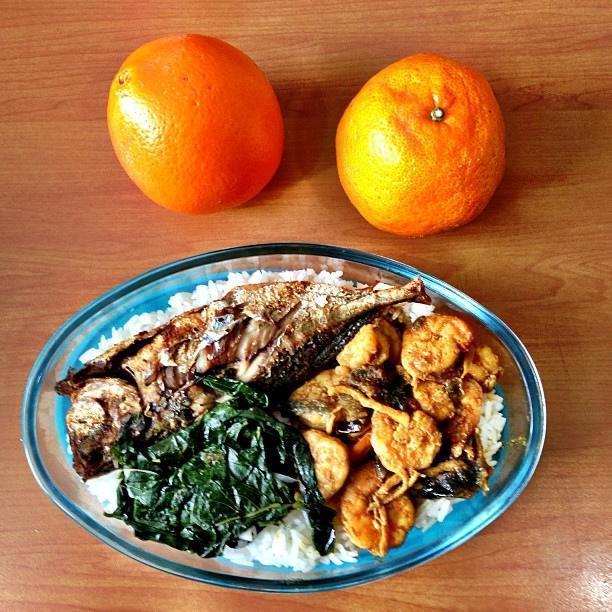How many oranges here?
Give a very brief answer. 2. How many oranges are there?
Give a very brief answer. 2. 